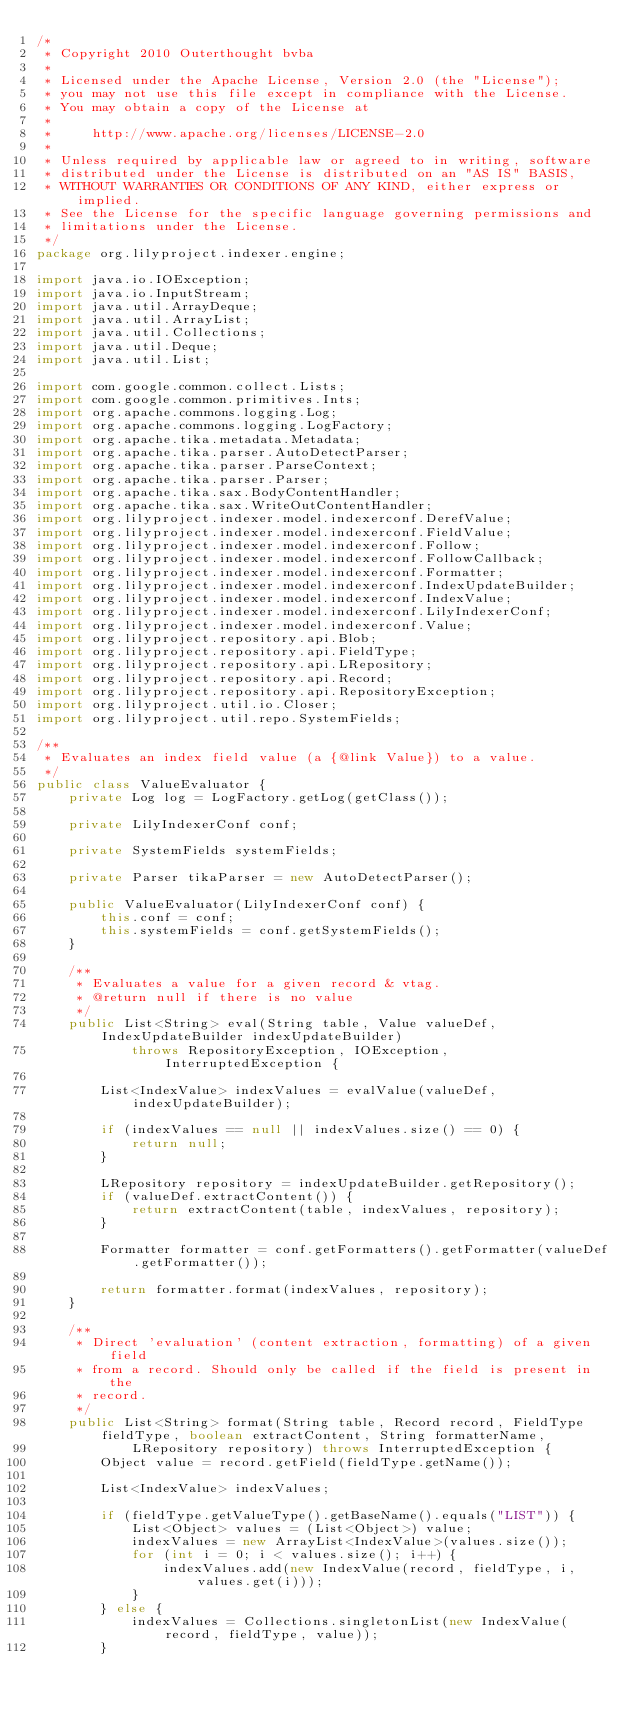Convert code to text. <code><loc_0><loc_0><loc_500><loc_500><_Java_>/*
 * Copyright 2010 Outerthought bvba
 *
 * Licensed under the Apache License, Version 2.0 (the "License");
 * you may not use this file except in compliance with the License.
 * You may obtain a copy of the License at
 *
 *     http://www.apache.org/licenses/LICENSE-2.0
 *
 * Unless required by applicable law or agreed to in writing, software
 * distributed under the License is distributed on an "AS IS" BASIS,
 * WITHOUT WARRANTIES OR CONDITIONS OF ANY KIND, either express or implied.
 * See the License for the specific language governing permissions and
 * limitations under the License.
 */
package org.lilyproject.indexer.engine;

import java.io.IOException;
import java.io.InputStream;
import java.util.ArrayDeque;
import java.util.ArrayList;
import java.util.Collections;
import java.util.Deque;
import java.util.List;

import com.google.common.collect.Lists;
import com.google.common.primitives.Ints;
import org.apache.commons.logging.Log;
import org.apache.commons.logging.LogFactory;
import org.apache.tika.metadata.Metadata;
import org.apache.tika.parser.AutoDetectParser;
import org.apache.tika.parser.ParseContext;
import org.apache.tika.parser.Parser;
import org.apache.tika.sax.BodyContentHandler;
import org.apache.tika.sax.WriteOutContentHandler;
import org.lilyproject.indexer.model.indexerconf.DerefValue;
import org.lilyproject.indexer.model.indexerconf.FieldValue;
import org.lilyproject.indexer.model.indexerconf.Follow;
import org.lilyproject.indexer.model.indexerconf.FollowCallback;
import org.lilyproject.indexer.model.indexerconf.Formatter;
import org.lilyproject.indexer.model.indexerconf.IndexUpdateBuilder;
import org.lilyproject.indexer.model.indexerconf.IndexValue;
import org.lilyproject.indexer.model.indexerconf.LilyIndexerConf;
import org.lilyproject.indexer.model.indexerconf.Value;
import org.lilyproject.repository.api.Blob;
import org.lilyproject.repository.api.FieldType;
import org.lilyproject.repository.api.LRepository;
import org.lilyproject.repository.api.Record;
import org.lilyproject.repository.api.RepositoryException;
import org.lilyproject.util.io.Closer;
import org.lilyproject.util.repo.SystemFields;

/**
 * Evaluates an index field value (a {@link Value}) to a value.
 */
public class ValueEvaluator {
    private Log log = LogFactory.getLog(getClass());

    private LilyIndexerConf conf;

    private SystemFields systemFields;

    private Parser tikaParser = new AutoDetectParser();

    public ValueEvaluator(LilyIndexerConf conf) {
        this.conf = conf;
        this.systemFields = conf.getSystemFields();
    }

    /**
     * Evaluates a value for a given record & vtag.
     * @return null if there is no value
     */
    public List<String> eval(String table, Value valueDef, IndexUpdateBuilder indexUpdateBuilder)
            throws RepositoryException, IOException, InterruptedException {

        List<IndexValue> indexValues = evalValue(valueDef, indexUpdateBuilder);

        if (indexValues == null || indexValues.size() == 0) {
            return null;
        }

        LRepository repository = indexUpdateBuilder.getRepository();
        if (valueDef.extractContent()) {
            return extractContent(table, indexValues, repository);
        }

        Formatter formatter = conf.getFormatters().getFormatter(valueDef.getFormatter());

        return formatter.format(indexValues, repository);
    }

    /**
     * Direct 'evaluation' (content extraction, formatting) of a given field
     * from a record. Should only be called if the field is present in the
     * record.
     */
    public List<String> format(String table, Record record, FieldType fieldType, boolean extractContent, String formatterName,
            LRepository repository) throws InterruptedException {
        Object value = record.getField(fieldType.getName());

        List<IndexValue> indexValues;

        if (fieldType.getValueType().getBaseName().equals("LIST")) {
            List<Object> values = (List<Object>) value;
            indexValues = new ArrayList<IndexValue>(values.size());
            for (int i = 0; i < values.size(); i++) {
                indexValues.add(new IndexValue(record, fieldType, i, values.get(i)));
            }
        } else {
            indexValues = Collections.singletonList(new IndexValue(record, fieldType, value));
        }
</code> 